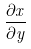Convert formula to latex. <formula><loc_0><loc_0><loc_500><loc_500>\frac { \partial x } { \partial y }</formula> 